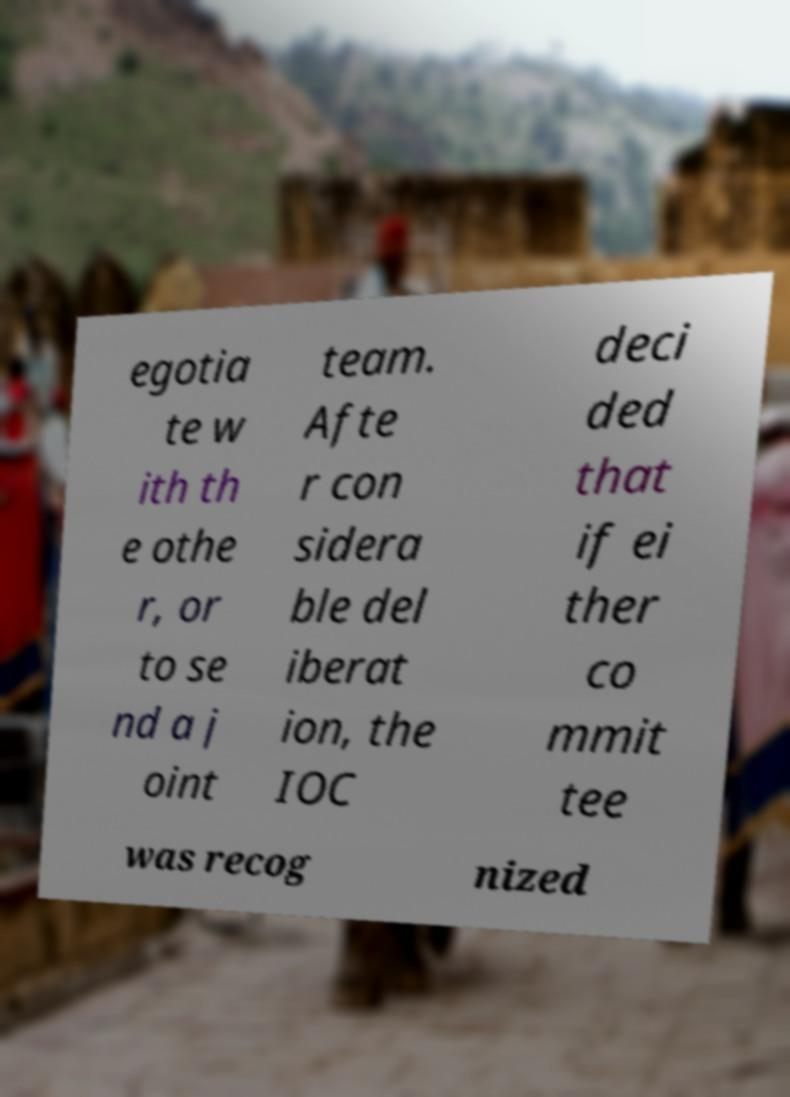What messages or text are displayed in this image? I need them in a readable, typed format. egotia te w ith th e othe r, or to se nd a j oint team. Afte r con sidera ble del iberat ion, the IOC deci ded that if ei ther co mmit tee was recog nized 